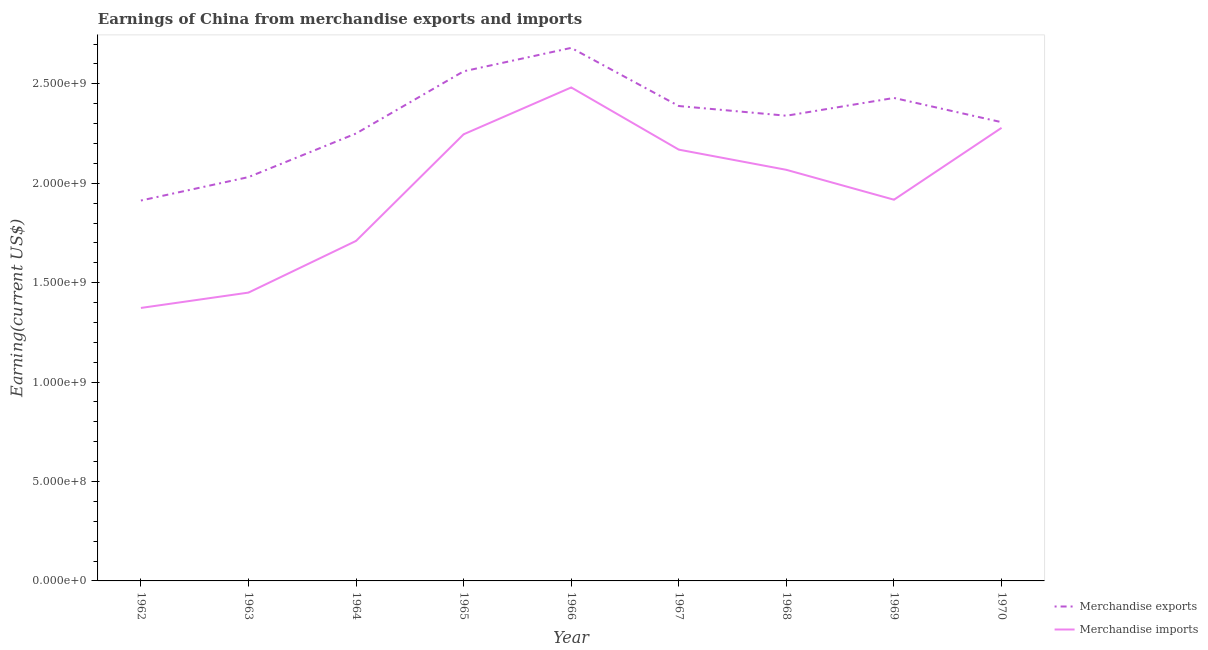How many different coloured lines are there?
Keep it short and to the point. 2. Does the line corresponding to earnings from merchandise imports intersect with the line corresponding to earnings from merchandise exports?
Your response must be concise. No. Is the number of lines equal to the number of legend labels?
Your response must be concise. Yes. What is the earnings from merchandise exports in 1963?
Give a very brief answer. 2.03e+09. Across all years, what is the maximum earnings from merchandise exports?
Your answer should be compact. 2.68e+09. Across all years, what is the minimum earnings from merchandise imports?
Make the answer very short. 1.37e+09. In which year was the earnings from merchandise imports maximum?
Offer a very short reply. 1966. In which year was the earnings from merchandise exports minimum?
Provide a succinct answer. 1962. What is the total earnings from merchandise imports in the graph?
Your answer should be compact. 1.77e+1. What is the difference between the earnings from merchandise imports in 1966 and that in 1970?
Your answer should be very brief. 2.03e+08. What is the difference between the earnings from merchandise exports in 1966 and the earnings from merchandise imports in 1970?
Provide a short and direct response. 4.02e+08. What is the average earnings from merchandise exports per year?
Provide a succinct answer. 2.32e+09. In the year 1963, what is the difference between the earnings from merchandise exports and earnings from merchandise imports?
Make the answer very short. 5.81e+08. In how many years, is the earnings from merchandise exports greater than 1400000000 US$?
Your answer should be compact. 9. What is the ratio of the earnings from merchandise exports in 1963 to that in 1965?
Provide a short and direct response. 0.79. What is the difference between the highest and the second highest earnings from merchandise imports?
Ensure brevity in your answer.  2.03e+08. What is the difference between the highest and the lowest earnings from merchandise imports?
Give a very brief answer. 1.11e+09. Is the earnings from merchandise exports strictly less than the earnings from merchandise imports over the years?
Your response must be concise. No. Does the graph contain grids?
Offer a very short reply. No. Where does the legend appear in the graph?
Provide a short and direct response. Bottom right. How are the legend labels stacked?
Keep it short and to the point. Vertical. What is the title of the graph?
Provide a succinct answer. Earnings of China from merchandise exports and imports. Does "Highest 20% of population" appear as one of the legend labels in the graph?
Make the answer very short. No. What is the label or title of the X-axis?
Give a very brief answer. Year. What is the label or title of the Y-axis?
Offer a very short reply. Earning(current US$). What is the Earning(current US$) of Merchandise exports in 1962?
Provide a succinct answer. 1.91e+09. What is the Earning(current US$) of Merchandise imports in 1962?
Give a very brief answer. 1.37e+09. What is the Earning(current US$) in Merchandise exports in 1963?
Offer a very short reply. 2.03e+09. What is the Earning(current US$) in Merchandise imports in 1963?
Your response must be concise. 1.45e+09. What is the Earning(current US$) in Merchandise exports in 1964?
Keep it short and to the point. 2.25e+09. What is the Earning(current US$) of Merchandise imports in 1964?
Your answer should be compact. 1.71e+09. What is the Earning(current US$) in Merchandise exports in 1965?
Ensure brevity in your answer.  2.56e+09. What is the Earning(current US$) in Merchandise imports in 1965?
Your answer should be very brief. 2.25e+09. What is the Earning(current US$) in Merchandise exports in 1966?
Make the answer very short. 2.68e+09. What is the Earning(current US$) in Merchandise imports in 1966?
Ensure brevity in your answer.  2.48e+09. What is the Earning(current US$) in Merchandise exports in 1967?
Provide a succinct answer. 2.39e+09. What is the Earning(current US$) in Merchandise imports in 1967?
Ensure brevity in your answer.  2.17e+09. What is the Earning(current US$) of Merchandise exports in 1968?
Your response must be concise. 2.34e+09. What is the Earning(current US$) in Merchandise imports in 1968?
Your response must be concise. 2.07e+09. What is the Earning(current US$) of Merchandise exports in 1969?
Your answer should be very brief. 2.43e+09. What is the Earning(current US$) of Merchandise imports in 1969?
Ensure brevity in your answer.  1.92e+09. What is the Earning(current US$) in Merchandise exports in 1970?
Offer a very short reply. 2.31e+09. What is the Earning(current US$) in Merchandise imports in 1970?
Your answer should be compact. 2.28e+09. Across all years, what is the maximum Earning(current US$) in Merchandise exports?
Make the answer very short. 2.68e+09. Across all years, what is the maximum Earning(current US$) in Merchandise imports?
Provide a succinct answer. 2.48e+09. Across all years, what is the minimum Earning(current US$) of Merchandise exports?
Ensure brevity in your answer.  1.91e+09. Across all years, what is the minimum Earning(current US$) in Merchandise imports?
Your answer should be very brief. 1.37e+09. What is the total Earning(current US$) in Merchandise exports in the graph?
Offer a very short reply. 2.09e+1. What is the total Earning(current US$) in Merchandise imports in the graph?
Make the answer very short. 1.77e+1. What is the difference between the Earning(current US$) of Merchandise exports in 1962 and that in 1963?
Make the answer very short. -1.18e+08. What is the difference between the Earning(current US$) in Merchandise imports in 1962 and that in 1963?
Your answer should be compact. -7.72e+07. What is the difference between the Earning(current US$) of Merchandise exports in 1962 and that in 1964?
Make the answer very short. -3.37e+08. What is the difference between the Earning(current US$) in Merchandise imports in 1962 and that in 1964?
Your answer should be compact. -3.37e+08. What is the difference between the Earning(current US$) of Merchandise exports in 1962 and that in 1965?
Offer a very short reply. -6.50e+08. What is the difference between the Earning(current US$) of Merchandise imports in 1962 and that in 1965?
Your response must be concise. -8.73e+08. What is the difference between the Earning(current US$) of Merchandise exports in 1962 and that in 1966?
Keep it short and to the point. -7.68e+08. What is the difference between the Earning(current US$) in Merchandise imports in 1962 and that in 1966?
Make the answer very short. -1.11e+09. What is the difference between the Earning(current US$) in Merchandise exports in 1962 and that in 1967?
Make the answer very short. -4.75e+08. What is the difference between the Earning(current US$) of Merchandise imports in 1962 and that in 1967?
Offer a terse response. -7.96e+08. What is the difference between the Earning(current US$) in Merchandise exports in 1962 and that in 1968?
Offer a terse response. -4.27e+08. What is the difference between the Earning(current US$) in Merchandise imports in 1962 and that in 1968?
Offer a very short reply. -6.95e+08. What is the difference between the Earning(current US$) in Merchandise exports in 1962 and that in 1969?
Your response must be concise. -5.16e+08. What is the difference between the Earning(current US$) in Merchandise imports in 1962 and that in 1969?
Your answer should be very brief. -5.44e+08. What is the difference between the Earning(current US$) of Merchandise exports in 1962 and that in 1970?
Give a very brief answer. -3.94e+08. What is the difference between the Earning(current US$) of Merchandise imports in 1962 and that in 1970?
Give a very brief answer. -9.06e+08. What is the difference between the Earning(current US$) in Merchandise exports in 1963 and that in 1964?
Offer a terse response. -2.19e+08. What is the difference between the Earning(current US$) of Merchandise imports in 1963 and that in 1964?
Give a very brief answer. -2.60e+08. What is the difference between the Earning(current US$) in Merchandise exports in 1963 and that in 1965?
Give a very brief answer. -5.32e+08. What is the difference between the Earning(current US$) in Merchandise imports in 1963 and that in 1965?
Your answer should be very brief. -7.96e+08. What is the difference between the Earning(current US$) of Merchandise exports in 1963 and that in 1966?
Offer a very short reply. -6.50e+08. What is the difference between the Earning(current US$) in Merchandise imports in 1963 and that in 1966?
Your answer should be very brief. -1.03e+09. What is the difference between the Earning(current US$) in Merchandise exports in 1963 and that in 1967?
Offer a terse response. -3.57e+08. What is the difference between the Earning(current US$) in Merchandise imports in 1963 and that in 1967?
Your response must be concise. -7.19e+08. What is the difference between the Earning(current US$) of Merchandise exports in 1963 and that in 1968?
Your answer should be very brief. -3.09e+08. What is the difference between the Earning(current US$) in Merchandise imports in 1963 and that in 1968?
Make the answer very short. -6.17e+08. What is the difference between the Earning(current US$) in Merchandise exports in 1963 and that in 1969?
Offer a very short reply. -3.98e+08. What is the difference between the Earning(current US$) in Merchandise imports in 1963 and that in 1969?
Provide a succinct answer. -4.67e+08. What is the difference between the Earning(current US$) in Merchandise exports in 1963 and that in 1970?
Ensure brevity in your answer.  -2.76e+08. What is the difference between the Earning(current US$) in Merchandise imports in 1963 and that in 1970?
Give a very brief answer. -8.29e+08. What is the difference between the Earning(current US$) of Merchandise exports in 1964 and that in 1965?
Your answer should be very brief. -3.13e+08. What is the difference between the Earning(current US$) of Merchandise imports in 1964 and that in 1965?
Make the answer very short. -5.36e+08. What is the difference between the Earning(current US$) in Merchandise exports in 1964 and that in 1966?
Ensure brevity in your answer.  -4.31e+08. What is the difference between the Earning(current US$) of Merchandise imports in 1964 and that in 1966?
Offer a very short reply. -7.72e+08. What is the difference between the Earning(current US$) of Merchandise exports in 1964 and that in 1967?
Your answer should be very brief. -1.38e+08. What is the difference between the Earning(current US$) in Merchandise imports in 1964 and that in 1967?
Your answer should be compact. -4.59e+08. What is the difference between the Earning(current US$) of Merchandise exports in 1964 and that in 1968?
Provide a short and direct response. -8.94e+07. What is the difference between the Earning(current US$) in Merchandise imports in 1964 and that in 1968?
Your answer should be very brief. -3.57e+08. What is the difference between the Earning(current US$) in Merchandise exports in 1964 and that in 1969?
Your answer should be very brief. -1.79e+08. What is the difference between the Earning(current US$) of Merchandise imports in 1964 and that in 1969?
Offer a terse response. -2.07e+08. What is the difference between the Earning(current US$) of Merchandise exports in 1964 and that in 1970?
Your response must be concise. -5.69e+07. What is the difference between the Earning(current US$) in Merchandise imports in 1964 and that in 1970?
Keep it short and to the point. -5.69e+08. What is the difference between the Earning(current US$) in Merchandise exports in 1965 and that in 1966?
Provide a short and direct response. -1.18e+08. What is the difference between the Earning(current US$) of Merchandise imports in 1965 and that in 1966?
Keep it short and to the point. -2.36e+08. What is the difference between the Earning(current US$) of Merchandise exports in 1965 and that in 1967?
Give a very brief answer. 1.75e+08. What is the difference between the Earning(current US$) in Merchandise imports in 1965 and that in 1967?
Give a very brief answer. 7.72e+07. What is the difference between the Earning(current US$) of Merchandise exports in 1965 and that in 1968?
Provide a succinct answer. 2.23e+08. What is the difference between the Earning(current US$) in Merchandise imports in 1965 and that in 1968?
Provide a succinct answer. 1.79e+08. What is the difference between the Earning(current US$) in Merchandise exports in 1965 and that in 1969?
Your response must be concise. 1.34e+08. What is the difference between the Earning(current US$) of Merchandise imports in 1965 and that in 1969?
Your answer should be very brief. 3.29e+08. What is the difference between the Earning(current US$) of Merchandise exports in 1965 and that in 1970?
Give a very brief answer. 2.56e+08. What is the difference between the Earning(current US$) of Merchandise imports in 1965 and that in 1970?
Provide a short and direct response. -3.25e+07. What is the difference between the Earning(current US$) in Merchandise exports in 1966 and that in 1967?
Offer a very short reply. 2.92e+08. What is the difference between the Earning(current US$) in Merchandise imports in 1966 and that in 1967?
Keep it short and to the point. 3.13e+08. What is the difference between the Earning(current US$) in Merchandise exports in 1966 and that in 1968?
Give a very brief answer. 3.41e+08. What is the difference between the Earning(current US$) of Merchandise imports in 1966 and that in 1968?
Ensure brevity in your answer.  4.14e+08. What is the difference between the Earning(current US$) of Merchandise exports in 1966 and that in 1969?
Your response must be concise. 2.52e+08. What is the difference between the Earning(current US$) in Merchandise imports in 1966 and that in 1969?
Provide a short and direct response. 5.65e+08. What is the difference between the Earning(current US$) in Merchandise exports in 1966 and that in 1970?
Offer a very short reply. 3.74e+08. What is the difference between the Earning(current US$) of Merchandise imports in 1966 and that in 1970?
Your answer should be compact. 2.03e+08. What is the difference between the Earning(current US$) of Merchandise exports in 1967 and that in 1968?
Provide a succinct answer. 4.88e+07. What is the difference between the Earning(current US$) of Merchandise imports in 1967 and that in 1968?
Offer a terse response. 1.02e+08. What is the difference between the Earning(current US$) in Merchandise exports in 1967 and that in 1969?
Offer a terse response. -4.06e+07. What is the difference between the Earning(current US$) of Merchandise imports in 1967 and that in 1969?
Offer a very short reply. 2.52e+08. What is the difference between the Earning(current US$) in Merchandise exports in 1967 and that in 1970?
Your response must be concise. 8.12e+07. What is the difference between the Earning(current US$) in Merchandise imports in 1967 and that in 1970?
Your answer should be compact. -1.10e+08. What is the difference between the Earning(current US$) in Merchandise exports in 1968 and that in 1969?
Provide a short and direct response. -8.94e+07. What is the difference between the Earning(current US$) of Merchandise imports in 1968 and that in 1969?
Ensure brevity in your answer.  1.50e+08. What is the difference between the Earning(current US$) of Merchandise exports in 1968 and that in 1970?
Offer a terse response. 3.25e+07. What is the difference between the Earning(current US$) in Merchandise imports in 1968 and that in 1970?
Keep it short and to the point. -2.11e+08. What is the difference between the Earning(current US$) of Merchandise exports in 1969 and that in 1970?
Give a very brief answer. 1.22e+08. What is the difference between the Earning(current US$) of Merchandise imports in 1969 and that in 1970?
Your answer should be compact. -3.62e+08. What is the difference between the Earning(current US$) of Merchandise exports in 1962 and the Earning(current US$) of Merchandise imports in 1963?
Keep it short and to the point. 4.63e+08. What is the difference between the Earning(current US$) in Merchandise exports in 1962 and the Earning(current US$) in Merchandise imports in 1964?
Your response must be concise. 2.03e+08. What is the difference between the Earning(current US$) in Merchandise exports in 1962 and the Earning(current US$) in Merchandise imports in 1965?
Offer a very short reply. -3.33e+08. What is the difference between the Earning(current US$) in Merchandise exports in 1962 and the Earning(current US$) in Merchandise imports in 1966?
Your response must be concise. -5.69e+08. What is the difference between the Earning(current US$) of Merchandise exports in 1962 and the Earning(current US$) of Merchandise imports in 1967?
Give a very brief answer. -2.56e+08. What is the difference between the Earning(current US$) in Merchandise exports in 1962 and the Earning(current US$) in Merchandise imports in 1968?
Ensure brevity in your answer.  -1.54e+08. What is the difference between the Earning(current US$) of Merchandise exports in 1962 and the Earning(current US$) of Merchandise imports in 1969?
Your answer should be very brief. -4.06e+06. What is the difference between the Earning(current US$) of Merchandise exports in 1962 and the Earning(current US$) of Merchandise imports in 1970?
Provide a short and direct response. -3.66e+08. What is the difference between the Earning(current US$) in Merchandise exports in 1963 and the Earning(current US$) in Merchandise imports in 1964?
Your response must be concise. 3.21e+08. What is the difference between the Earning(current US$) of Merchandise exports in 1963 and the Earning(current US$) of Merchandise imports in 1965?
Offer a very short reply. -2.15e+08. What is the difference between the Earning(current US$) of Merchandise exports in 1963 and the Earning(current US$) of Merchandise imports in 1966?
Keep it short and to the point. -4.51e+08. What is the difference between the Earning(current US$) of Merchandise exports in 1963 and the Earning(current US$) of Merchandise imports in 1967?
Offer a terse response. -1.38e+08. What is the difference between the Earning(current US$) in Merchandise exports in 1963 and the Earning(current US$) in Merchandise imports in 1968?
Offer a terse response. -3.66e+07. What is the difference between the Earning(current US$) in Merchandise exports in 1963 and the Earning(current US$) in Merchandise imports in 1969?
Provide a succinct answer. 1.14e+08. What is the difference between the Earning(current US$) of Merchandise exports in 1963 and the Earning(current US$) of Merchandise imports in 1970?
Your answer should be very brief. -2.48e+08. What is the difference between the Earning(current US$) of Merchandise exports in 1964 and the Earning(current US$) of Merchandise imports in 1965?
Your answer should be compact. 4.06e+06. What is the difference between the Earning(current US$) of Merchandise exports in 1964 and the Earning(current US$) of Merchandise imports in 1966?
Offer a terse response. -2.32e+08. What is the difference between the Earning(current US$) in Merchandise exports in 1964 and the Earning(current US$) in Merchandise imports in 1967?
Make the answer very short. 8.12e+07. What is the difference between the Earning(current US$) in Merchandise exports in 1964 and the Earning(current US$) in Merchandise imports in 1968?
Your answer should be compact. 1.83e+08. What is the difference between the Earning(current US$) in Merchandise exports in 1964 and the Earning(current US$) in Merchandise imports in 1969?
Your answer should be compact. 3.33e+08. What is the difference between the Earning(current US$) in Merchandise exports in 1964 and the Earning(current US$) in Merchandise imports in 1970?
Provide a succinct answer. -2.84e+07. What is the difference between the Earning(current US$) in Merchandise exports in 1965 and the Earning(current US$) in Merchandise imports in 1966?
Your answer should be very brief. 8.12e+07. What is the difference between the Earning(current US$) in Merchandise exports in 1965 and the Earning(current US$) in Merchandise imports in 1967?
Offer a very short reply. 3.94e+08. What is the difference between the Earning(current US$) in Merchandise exports in 1965 and the Earning(current US$) in Merchandise imports in 1968?
Keep it short and to the point. 4.96e+08. What is the difference between the Earning(current US$) of Merchandise exports in 1965 and the Earning(current US$) of Merchandise imports in 1969?
Provide a short and direct response. 6.46e+08. What is the difference between the Earning(current US$) in Merchandise exports in 1965 and the Earning(current US$) in Merchandise imports in 1970?
Your response must be concise. 2.84e+08. What is the difference between the Earning(current US$) in Merchandise exports in 1966 and the Earning(current US$) in Merchandise imports in 1967?
Make the answer very short. 5.12e+08. What is the difference between the Earning(current US$) in Merchandise exports in 1966 and the Earning(current US$) in Merchandise imports in 1968?
Offer a terse response. 6.13e+08. What is the difference between the Earning(current US$) of Merchandise exports in 1966 and the Earning(current US$) of Merchandise imports in 1969?
Ensure brevity in your answer.  7.64e+08. What is the difference between the Earning(current US$) of Merchandise exports in 1966 and the Earning(current US$) of Merchandise imports in 1970?
Keep it short and to the point. 4.02e+08. What is the difference between the Earning(current US$) in Merchandise exports in 1967 and the Earning(current US$) in Merchandise imports in 1968?
Provide a short and direct response. 3.21e+08. What is the difference between the Earning(current US$) in Merchandise exports in 1967 and the Earning(current US$) in Merchandise imports in 1969?
Offer a terse response. 4.71e+08. What is the difference between the Earning(current US$) in Merchandise exports in 1967 and the Earning(current US$) in Merchandise imports in 1970?
Your response must be concise. 1.10e+08. What is the difference between the Earning(current US$) in Merchandise exports in 1968 and the Earning(current US$) in Merchandise imports in 1969?
Your response must be concise. 4.22e+08. What is the difference between the Earning(current US$) of Merchandise exports in 1968 and the Earning(current US$) of Merchandise imports in 1970?
Your answer should be compact. 6.09e+07. What is the difference between the Earning(current US$) of Merchandise exports in 1969 and the Earning(current US$) of Merchandise imports in 1970?
Your response must be concise. 1.50e+08. What is the average Earning(current US$) in Merchandise exports per year?
Provide a succinct answer. 2.32e+09. What is the average Earning(current US$) of Merchandise imports per year?
Give a very brief answer. 1.97e+09. In the year 1962, what is the difference between the Earning(current US$) in Merchandise exports and Earning(current US$) in Merchandise imports?
Your answer should be very brief. 5.40e+08. In the year 1963, what is the difference between the Earning(current US$) in Merchandise exports and Earning(current US$) in Merchandise imports?
Provide a short and direct response. 5.81e+08. In the year 1964, what is the difference between the Earning(current US$) in Merchandise exports and Earning(current US$) in Merchandise imports?
Your response must be concise. 5.40e+08. In the year 1965, what is the difference between the Earning(current US$) in Merchandise exports and Earning(current US$) in Merchandise imports?
Offer a terse response. 3.17e+08. In the year 1966, what is the difference between the Earning(current US$) of Merchandise exports and Earning(current US$) of Merchandise imports?
Your answer should be compact. 1.99e+08. In the year 1967, what is the difference between the Earning(current US$) of Merchandise exports and Earning(current US$) of Merchandise imports?
Provide a short and direct response. 2.19e+08. In the year 1968, what is the difference between the Earning(current US$) in Merchandise exports and Earning(current US$) in Merchandise imports?
Provide a succinct answer. 2.72e+08. In the year 1969, what is the difference between the Earning(current US$) of Merchandise exports and Earning(current US$) of Merchandise imports?
Provide a succinct answer. 5.12e+08. In the year 1970, what is the difference between the Earning(current US$) of Merchandise exports and Earning(current US$) of Merchandise imports?
Offer a very short reply. 2.84e+07. What is the ratio of the Earning(current US$) of Merchandise exports in 1962 to that in 1963?
Keep it short and to the point. 0.94. What is the ratio of the Earning(current US$) in Merchandise imports in 1962 to that in 1963?
Offer a terse response. 0.95. What is the ratio of the Earning(current US$) in Merchandise exports in 1962 to that in 1964?
Make the answer very short. 0.85. What is the ratio of the Earning(current US$) in Merchandise imports in 1962 to that in 1964?
Provide a succinct answer. 0.8. What is the ratio of the Earning(current US$) in Merchandise exports in 1962 to that in 1965?
Your answer should be very brief. 0.75. What is the ratio of the Earning(current US$) of Merchandise imports in 1962 to that in 1965?
Provide a succinct answer. 0.61. What is the ratio of the Earning(current US$) in Merchandise exports in 1962 to that in 1966?
Make the answer very short. 0.71. What is the ratio of the Earning(current US$) of Merchandise imports in 1962 to that in 1966?
Provide a succinct answer. 0.55. What is the ratio of the Earning(current US$) in Merchandise exports in 1962 to that in 1967?
Offer a very short reply. 0.8. What is the ratio of the Earning(current US$) of Merchandise imports in 1962 to that in 1967?
Your answer should be very brief. 0.63. What is the ratio of the Earning(current US$) in Merchandise exports in 1962 to that in 1968?
Your response must be concise. 0.82. What is the ratio of the Earning(current US$) of Merchandise imports in 1962 to that in 1968?
Ensure brevity in your answer.  0.66. What is the ratio of the Earning(current US$) in Merchandise exports in 1962 to that in 1969?
Your answer should be compact. 0.79. What is the ratio of the Earning(current US$) in Merchandise imports in 1962 to that in 1969?
Provide a short and direct response. 0.72. What is the ratio of the Earning(current US$) in Merchandise exports in 1962 to that in 1970?
Your answer should be very brief. 0.83. What is the ratio of the Earning(current US$) in Merchandise imports in 1962 to that in 1970?
Your answer should be compact. 0.6. What is the ratio of the Earning(current US$) in Merchandise exports in 1963 to that in 1964?
Provide a succinct answer. 0.9. What is the ratio of the Earning(current US$) in Merchandise imports in 1963 to that in 1964?
Make the answer very short. 0.85. What is the ratio of the Earning(current US$) of Merchandise exports in 1963 to that in 1965?
Provide a short and direct response. 0.79. What is the ratio of the Earning(current US$) of Merchandise imports in 1963 to that in 1965?
Your answer should be very brief. 0.65. What is the ratio of the Earning(current US$) of Merchandise exports in 1963 to that in 1966?
Your answer should be compact. 0.76. What is the ratio of the Earning(current US$) in Merchandise imports in 1963 to that in 1966?
Offer a terse response. 0.58. What is the ratio of the Earning(current US$) in Merchandise exports in 1963 to that in 1967?
Your answer should be compact. 0.85. What is the ratio of the Earning(current US$) of Merchandise imports in 1963 to that in 1967?
Offer a terse response. 0.67. What is the ratio of the Earning(current US$) of Merchandise exports in 1963 to that in 1968?
Offer a terse response. 0.87. What is the ratio of the Earning(current US$) of Merchandise imports in 1963 to that in 1968?
Your answer should be very brief. 0.7. What is the ratio of the Earning(current US$) of Merchandise exports in 1963 to that in 1969?
Make the answer very short. 0.84. What is the ratio of the Earning(current US$) of Merchandise imports in 1963 to that in 1969?
Give a very brief answer. 0.76. What is the ratio of the Earning(current US$) of Merchandise exports in 1963 to that in 1970?
Offer a very short reply. 0.88. What is the ratio of the Earning(current US$) in Merchandise imports in 1963 to that in 1970?
Ensure brevity in your answer.  0.64. What is the ratio of the Earning(current US$) of Merchandise exports in 1964 to that in 1965?
Provide a short and direct response. 0.88. What is the ratio of the Earning(current US$) of Merchandise imports in 1964 to that in 1965?
Provide a short and direct response. 0.76. What is the ratio of the Earning(current US$) in Merchandise exports in 1964 to that in 1966?
Your answer should be compact. 0.84. What is the ratio of the Earning(current US$) of Merchandise imports in 1964 to that in 1966?
Your answer should be very brief. 0.69. What is the ratio of the Earning(current US$) in Merchandise exports in 1964 to that in 1967?
Offer a very short reply. 0.94. What is the ratio of the Earning(current US$) of Merchandise imports in 1964 to that in 1967?
Make the answer very short. 0.79. What is the ratio of the Earning(current US$) in Merchandise exports in 1964 to that in 1968?
Give a very brief answer. 0.96. What is the ratio of the Earning(current US$) of Merchandise imports in 1964 to that in 1968?
Ensure brevity in your answer.  0.83. What is the ratio of the Earning(current US$) in Merchandise exports in 1964 to that in 1969?
Your answer should be very brief. 0.93. What is the ratio of the Earning(current US$) in Merchandise imports in 1964 to that in 1969?
Make the answer very short. 0.89. What is the ratio of the Earning(current US$) in Merchandise exports in 1964 to that in 1970?
Keep it short and to the point. 0.98. What is the ratio of the Earning(current US$) in Merchandise imports in 1964 to that in 1970?
Offer a terse response. 0.75. What is the ratio of the Earning(current US$) of Merchandise exports in 1965 to that in 1966?
Offer a terse response. 0.96. What is the ratio of the Earning(current US$) in Merchandise imports in 1965 to that in 1966?
Your answer should be compact. 0.91. What is the ratio of the Earning(current US$) in Merchandise exports in 1965 to that in 1967?
Your response must be concise. 1.07. What is the ratio of the Earning(current US$) in Merchandise imports in 1965 to that in 1967?
Make the answer very short. 1.04. What is the ratio of the Earning(current US$) of Merchandise exports in 1965 to that in 1968?
Provide a short and direct response. 1.1. What is the ratio of the Earning(current US$) in Merchandise imports in 1965 to that in 1968?
Offer a terse response. 1.09. What is the ratio of the Earning(current US$) in Merchandise exports in 1965 to that in 1969?
Provide a succinct answer. 1.06. What is the ratio of the Earning(current US$) in Merchandise imports in 1965 to that in 1969?
Make the answer very short. 1.17. What is the ratio of the Earning(current US$) of Merchandise exports in 1965 to that in 1970?
Give a very brief answer. 1.11. What is the ratio of the Earning(current US$) of Merchandise imports in 1965 to that in 1970?
Provide a succinct answer. 0.99. What is the ratio of the Earning(current US$) in Merchandise exports in 1966 to that in 1967?
Your answer should be very brief. 1.12. What is the ratio of the Earning(current US$) of Merchandise imports in 1966 to that in 1967?
Your answer should be compact. 1.14. What is the ratio of the Earning(current US$) of Merchandise exports in 1966 to that in 1968?
Your answer should be compact. 1.15. What is the ratio of the Earning(current US$) in Merchandise imports in 1966 to that in 1968?
Provide a short and direct response. 1.2. What is the ratio of the Earning(current US$) in Merchandise exports in 1966 to that in 1969?
Keep it short and to the point. 1.1. What is the ratio of the Earning(current US$) of Merchandise imports in 1966 to that in 1969?
Provide a short and direct response. 1.29. What is the ratio of the Earning(current US$) in Merchandise exports in 1966 to that in 1970?
Give a very brief answer. 1.16. What is the ratio of the Earning(current US$) in Merchandise imports in 1966 to that in 1970?
Provide a short and direct response. 1.09. What is the ratio of the Earning(current US$) in Merchandise exports in 1967 to that in 1968?
Provide a succinct answer. 1.02. What is the ratio of the Earning(current US$) in Merchandise imports in 1967 to that in 1968?
Ensure brevity in your answer.  1.05. What is the ratio of the Earning(current US$) in Merchandise exports in 1967 to that in 1969?
Provide a short and direct response. 0.98. What is the ratio of the Earning(current US$) in Merchandise imports in 1967 to that in 1969?
Give a very brief answer. 1.13. What is the ratio of the Earning(current US$) of Merchandise exports in 1967 to that in 1970?
Offer a very short reply. 1.04. What is the ratio of the Earning(current US$) in Merchandise imports in 1967 to that in 1970?
Keep it short and to the point. 0.95. What is the ratio of the Earning(current US$) in Merchandise exports in 1968 to that in 1969?
Offer a terse response. 0.96. What is the ratio of the Earning(current US$) in Merchandise imports in 1968 to that in 1969?
Your response must be concise. 1.08. What is the ratio of the Earning(current US$) in Merchandise exports in 1968 to that in 1970?
Make the answer very short. 1.01. What is the ratio of the Earning(current US$) of Merchandise imports in 1968 to that in 1970?
Give a very brief answer. 0.91. What is the ratio of the Earning(current US$) of Merchandise exports in 1969 to that in 1970?
Provide a short and direct response. 1.05. What is the ratio of the Earning(current US$) of Merchandise imports in 1969 to that in 1970?
Make the answer very short. 0.84. What is the difference between the highest and the second highest Earning(current US$) of Merchandise exports?
Ensure brevity in your answer.  1.18e+08. What is the difference between the highest and the second highest Earning(current US$) in Merchandise imports?
Ensure brevity in your answer.  2.03e+08. What is the difference between the highest and the lowest Earning(current US$) in Merchandise exports?
Keep it short and to the point. 7.68e+08. What is the difference between the highest and the lowest Earning(current US$) of Merchandise imports?
Offer a very short reply. 1.11e+09. 